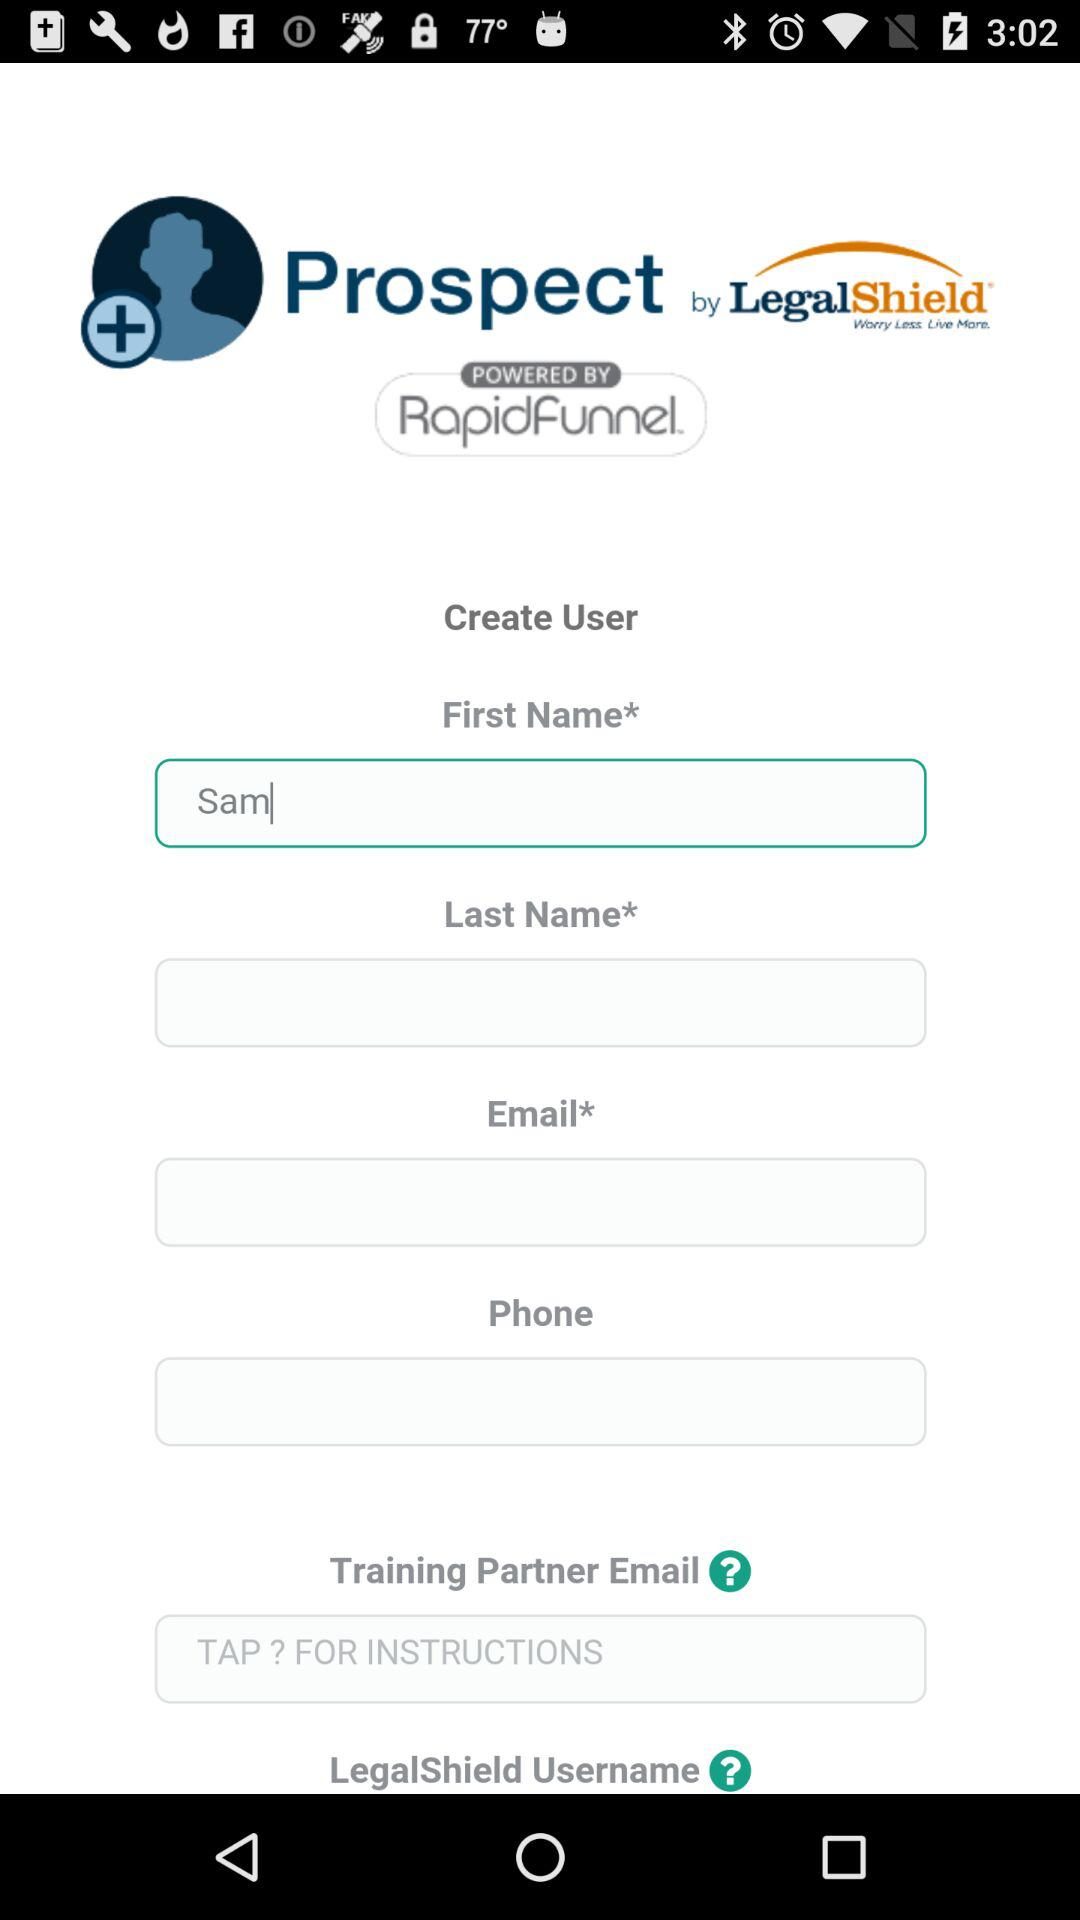What is the first name? The first name is Sam. 